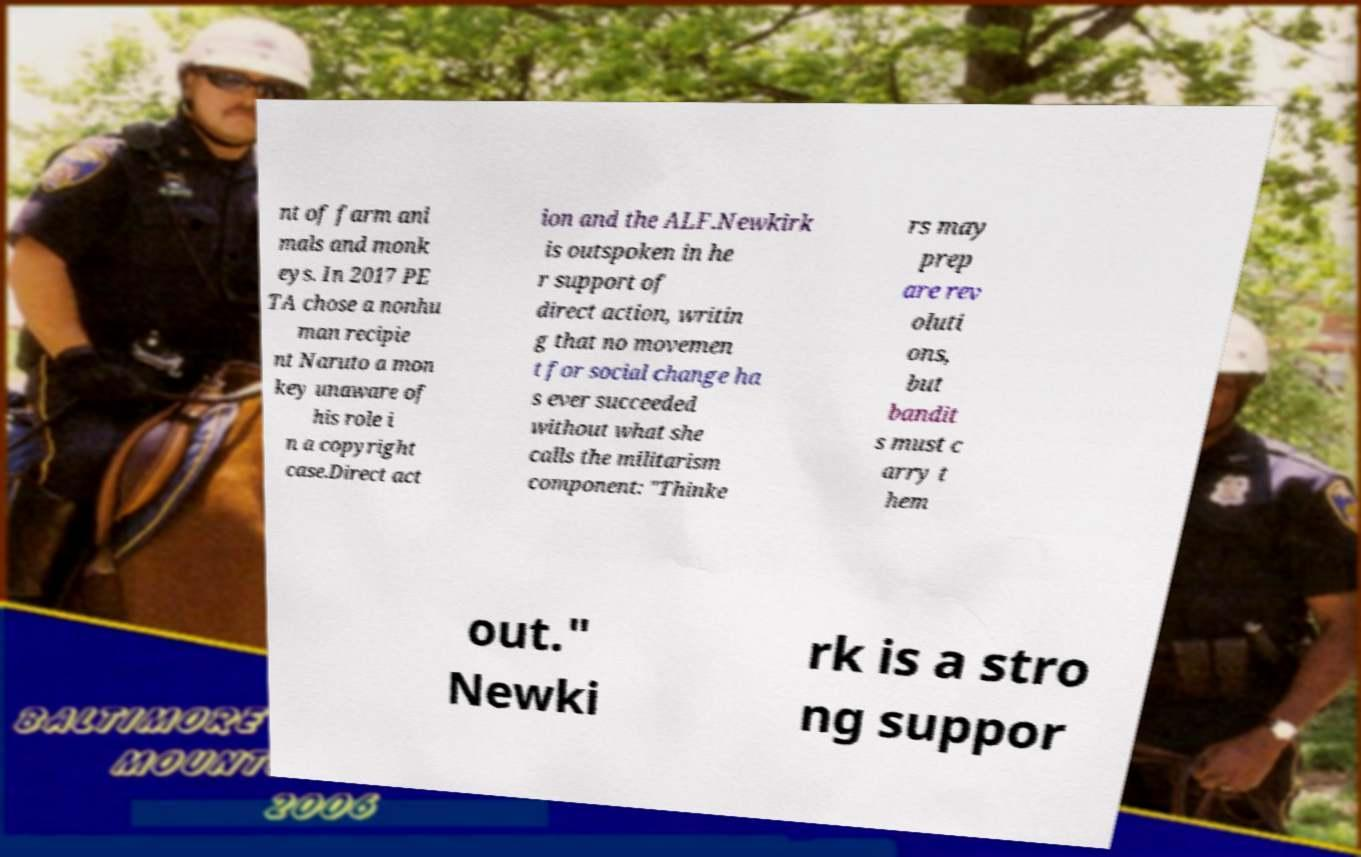Could you assist in decoding the text presented in this image and type it out clearly? nt of farm ani mals and monk eys. In 2017 PE TA chose a nonhu man recipie nt Naruto a mon key unaware of his role i n a copyright case.Direct act ion and the ALF.Newkirk is outspoken in he r support of direct action, writin g that no movemen t for social change ha s ever succeeded without what she calls the militarism component: "Thinke rs may prep are rev oluti ons, but bandit s must c arry t hem out." Newki rk is a stro ng suppor 